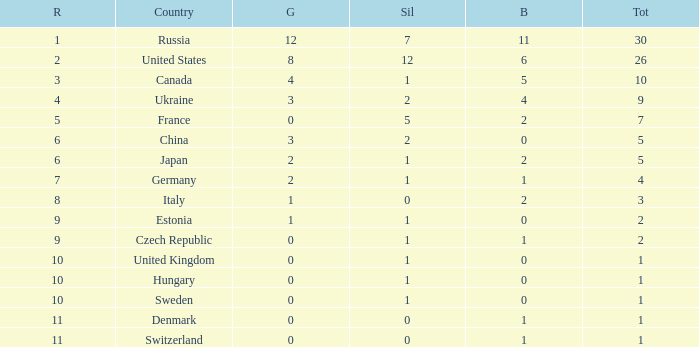Which silver has a Gold smaller than 12, a Rank smaller than 5, and a Bronze of 5? 1.0. 